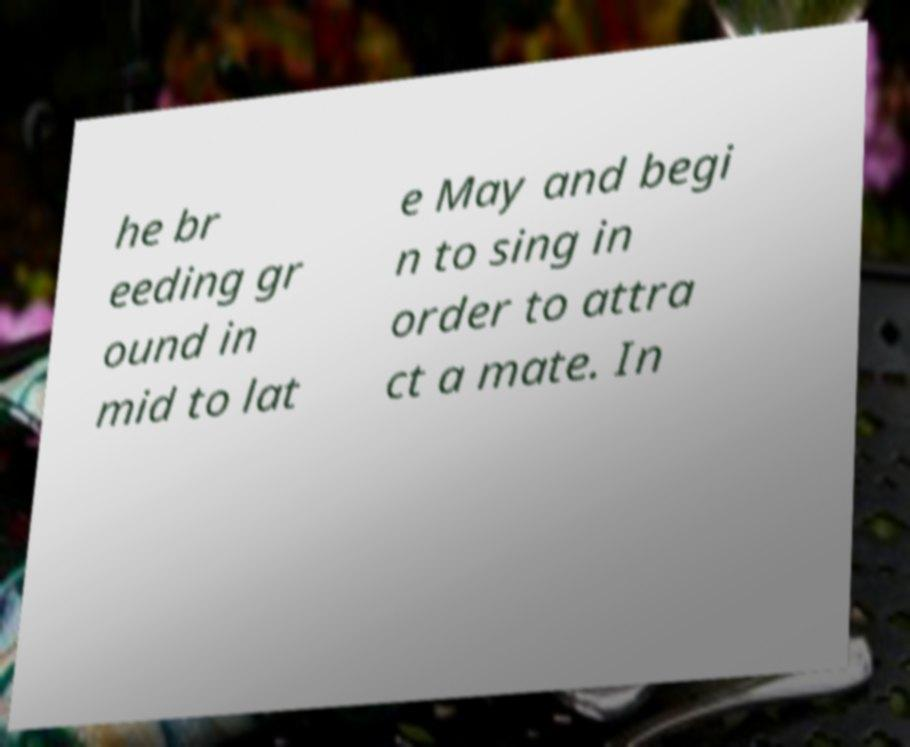Could you extract and type out the text from this image? he br eeding gr ound in mid to lat e May and begi n to sing in order to attra ct a mate. In 